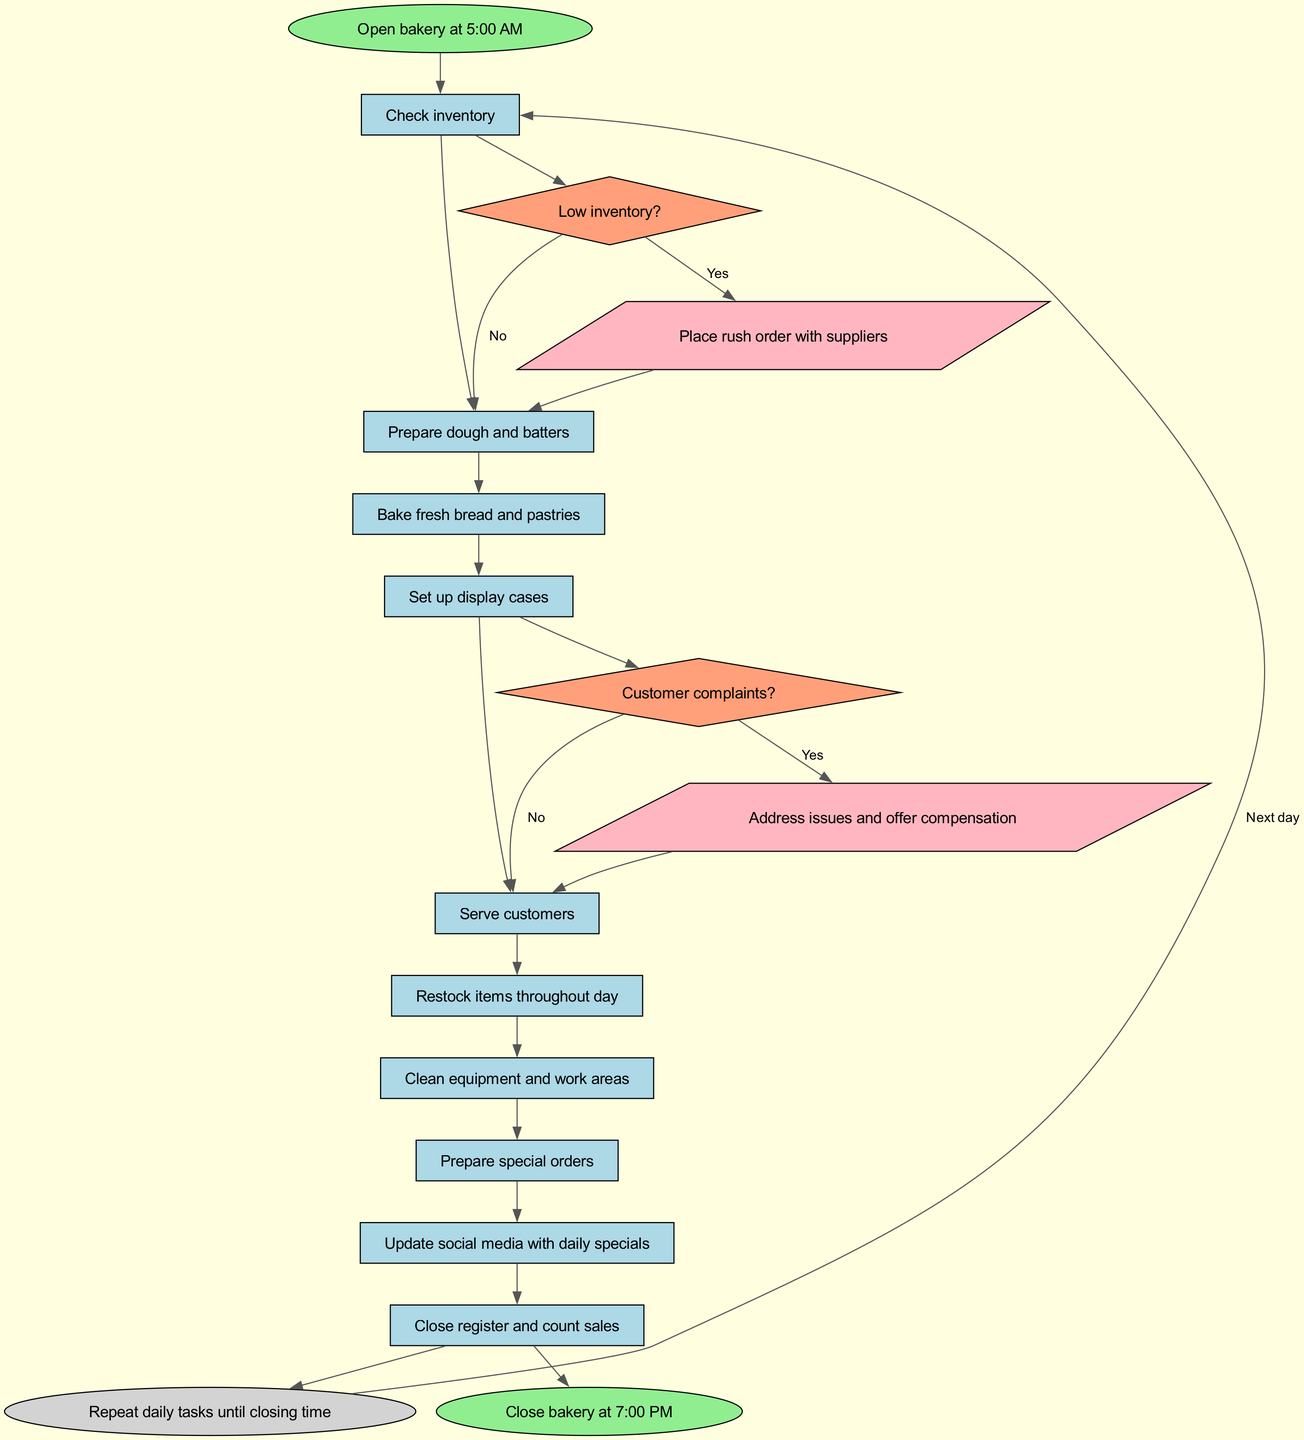What time does the bakery open? The diagram specifies the opening time of the bakery directly in the start node, which is 5:00 AM.
Answer: 5:00 AM What is the last step before closing? According to the diagram, the last step before closing is "Close register and count sales," which is the final action taken during operations.
Answer: Close register and count sales How many decisions are in the diagram? By examining the decisions section of the diagram, there are 2 distinct decision points: one for low inventory and another for customer complaints.
Answer: 2 What follows after "Check inventory"? The diagram clearly indicates that "Prepare dough and batters" follows immediately after "Check inventory," showing the sequential order of steps.
Answer: Prepare dough and batters What action is taken if inventory is low? The decision node connected to the "Low inventory?" condition shows that if the inventory is low, the action taken is to "Place rush order with suppliers."
Answer: Place rush order with suppliers What happens if there are customer complaints? If there are customer complaints, the diagram states that the bakery will "Address issues and offer compensation," demonstrating the course of action for that condition.
Answer: Address issues and offer compensation What is the condition for looping back to daily tasks? The loop in the diagram is defined as "Repeat daily tasks until closing time," indicating that daily operations are consistent until the closing procedure begins.
Answer: Repeat daily tasks until closing time How many steps are listed in the daily operations? The steps section outlines a total of 10 distinct operations the bakery performs daily, from opening to closing time.
Answer: 10 